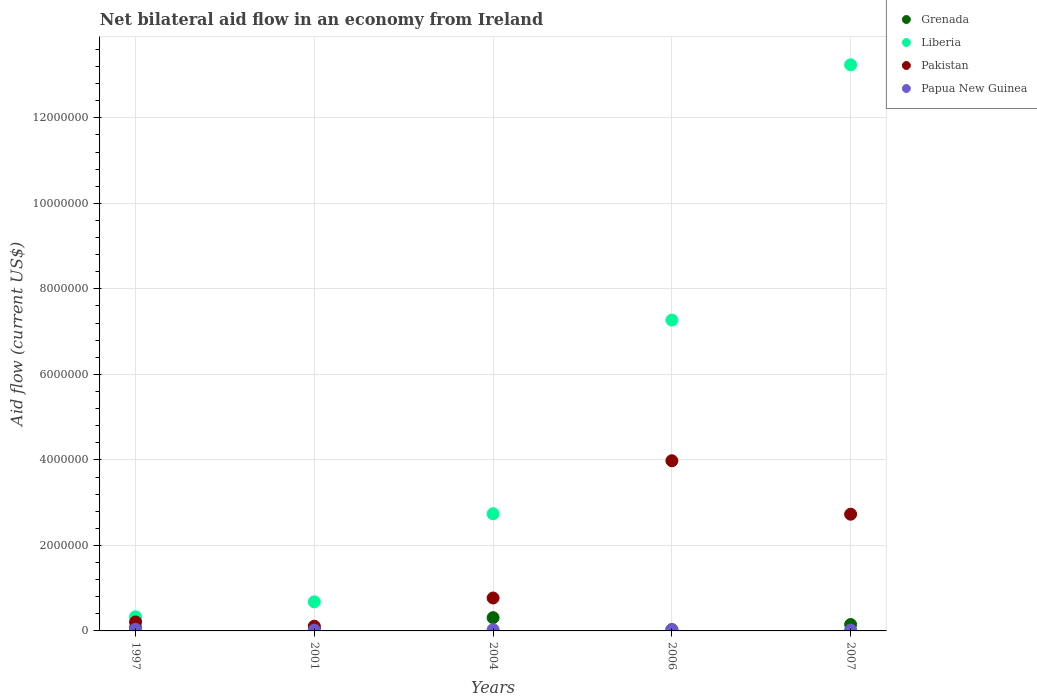How many different coloured dotlines are there?
Your response must be concise. 4. Is the number of dotlines equal to the number of legend labels?
Ensure brevity in your answer.  Yes. What is the net bilateral aid flow in Papua New Guinea in 2001?
Ensure brevity in your answer.  2.00e+04. Across all years, what is the maximum net bilateral aid flow in Pakistan?
Keep it short and to the point. 3.98e+06. Across all years, what is the minimum net bilateral aid flow in Grenada?
Make the answer very short. 3.00e+04. What is the total net bilateral aid flow in Pakistan in the graph?
Your answer should be very brief. 7.80e+06. What is the difference between the net bilateral aid flow in Pakistan in 2004 and that in 2006?
Offer a very short reply. -3.21e+06. What is the difference between the net bilateral aid flow in Liberia in 1997 and the net bilateral aid flow in Papua New Guinea in 2007?
Offer a very short reply. 3.10e+05. What is the average net bilateral aid flow in Liberia per year?
Your response must be concise. 4.85e+06. In the year 2001, what is the difference between the net bilateral aid flow in Pakistan and net bilateral aid flow in Grenada?
Ensure brevity in your answer.  6.00e+04. What is the ratio of the net bilateral aid flow in Pakistan in 2001 to that in 2007?
Offer a terse response. 0.04. Is the net bilateral aid flow in Liberia in 2004 less than that in 2007?
Keep it short and to the point. Yes. Is the difference between the net bilateral aid flow in Pakistan in 2006 and 2007 greater than the difference between the net bilateral aid flow in Grenada in 2006 and 2007?
Offer a very short reply. Yes. Is the sum of the net bilateral aid flow in Pakistan in 2001 and 2006 greater than the maximum net bilateral aid flow in Liberia across all years?
Give a very brief answer. No. Is it the case that in every year, the sum of the net bilateral aid flow in Grenada and net bilateral aid flow in Papua New Guinea  is greater than the sum of net bilateral aid flow in Liberia and net bilateral aid flow in Pakistan?
Give a very brief answer. No. Does the net bilateral aid flow in Grenada monotonically increase over the years?
Your answer should be compact. No. Is the net bilateral aid flow in Grenada strictly less than the net bilateral aid flow in Papua New Guinea over the years?
Offer a very short reply. No. What is the difference between two consecutive major ticks on the Y-axis?
Offer a terse response. 2.00e+06. Are the values on the major ticks of Y-axis written in scientific E-notation?
Provide a short and direct response. No. Does the graph contain any zero values?
Provide a succinct answer. No. Where does the legend appear in the graph?
Give a very brief answer. Top right. What is the title of the graph?
Your response must be concise. Net bilateral aid flow in an economy from Ireland. Does "New Zealand" appear as one of the legend labels in the graph?
Keep it short and to the point. No. What is the label or title of the X-axis?
Ensure brevity in your answer.  Years. What is the label or title of the Y-axis?
Give a very brief answer. Aid flow (current US$). What is the Aid flow (current US$) in Grenada in 1997?
Provide a short and direct response. 8.00e+04. What is the Aid flow (current US$) of Liberia in 1997?
Make the answer very short. 3.30e+05. What is the Aid flow (current US$) of Papua New Guinea in 1997?
Provide a short and direct response. 4.00e+04. What is the Aid flow (current US$) in Grenada in 2001?
Make the answer very short. 5.00e+04. What is the Aid flow (current US$) in Liberia in 2001?
Provide a short and direct response. 6.80e+05. What is the Aid flow (current US$) of Papua New Guinea in 2001?
Keep it short and to the point. 2.00e+04. What is the Aid flow (current US$) of Grenada in 2004?
Keep it short and to the point. 3.10e+05. What is the Aid flow (current US$) of Liberia in 2004?
Keep it short and to the point. 2.74e+06. What is the Aid flow (current US$) of Pakistan in 2004?
Provide a succinct answer. 7.70e+05. What is the Aid flow (current US$) in Grenada in 2006?
Your response must be concise. 3.00e+04. What is the Aid flow (current US$) of Liberia in 2006?
Your answer should be very brief. 7.27e+06. What is the Aid flow (current US$) of Pakistan in 2006?
Provide a succinct answer. 3.98e+06. What is the Aid flow (current US$) in Grenada in 2007?
Provide a succinct answer. 1.50e+05. What is the Aid flow (current US$) in Liberia in 2007?
Your response must be concise. 1.32e+07. What is the Aid flow (current US$) in Pakistan in 2007?
Offer a terse response. 2.73e+06. What is the Aid flow (current US$) of Papua New Guinea in 2007?
Ensure brevity in your answer.  2.00e+04. Across all years, what is the maximum Aid flow (current US$) of Liberia?
Make the answer very short. 1.32e+07. Across all years, what is the maximum Aid flow (current US$) in Pakistan?
Offer a very short reply. 3.98e+06. Across all years, what is the maximum Aid flow (current US$) of Papua New Guinea?
Ensure brevity in your answer.  4.00e+04. Across all years, what is the minimum Aid flow (current US$) of Liberia?
Provide a succinct answer. 3.30e+05. Across all years, what is the minimum Aid flow (current US$) of Pakistan?
Provide a succinct answer. 1.10e+05. Across all years, what is the minimum Aid flow (current US$) in Papua New Guinea?
Keep it short and to the point. 2.00e+04. What is the total Aid flow (current US$) in Grenada in the graph?
Keep it short and to the point. 6.20e+05. What is the total Aid flow (current US$) in Liberia in the graph?
Keep it short and to the point. 2.43e+07. What is the total Aid flow (current US$) of Pakistan in the graph?
Give a very brief answer. 7.80e+06. What is the total Aid flow (current US$) of Papua New Guinea in the graph?
Your answer should be compact. 1.40e+05. What is the difference between the Aid flow (current US$) in Liberia in 1997 and that in 2001?
Ensure brevity in your answer.  -3.50e+05. What is the difference between the Aid flow (current US$) of Pakistan in 1997 and that in 2001?
Keep it short and to the point. 1.00e+05. What is the difference between the Aid flow (current US$) in Papua New Guinea in 1997 and that in 2001?
Keep it short and to the point. 2.00e+04. What is the difference between the Aid flow (current US$) of Liberia in 1997 and that in 2004?
Your answer should be compact. -2.41e+06. What is the difference between the Aid flow (current US$) in Pakistan in 1997 and that in 2004?
Your answer should be compact. -5.60e+05. What is the difference between the Aid flow (current US$) in Papua New Guinea in 1997 and that in 2004?
Provide a succinct answer. 10000. What is the difference between the Aid flow (current US$) in Grenada in 1997 and that in 2006?
Provide a succinct answer. 5.00e+04. What is the difference between the Aid flow (current US$) of Liberia in 1997 and that in 2006?
Your answer should be compact. -6.94e+06. What is the difference between the Aid flow (current US$) in Pakistan in 1997 and that in 2006?
Ensure brevity in your answer.  -3.77e+06. What is the difference between the Aid flow (current US$) in Papua New Guinea in 1997 and that in 2006?
Make the answer very short. 10000. What is the difference between the Aid flow (current US$) of Grenada in 1997 and that in 2007?
Provide a succinct answer. -7.00e+04. What is the difference between the Aid flow (current US$) in Liberia in 1997 and that in 2007?
Make the answer very short. -1.29e+07. What is the difference between the Aid flow (current US$) of Pakistan in 1997 and that in 2007?
Your answer should be compact. -2.52e+06. What is the difference between the Aid flow (current US$) of Papua New Guinea in 1997 and that in 2007?
Your answer should be very brief. 2.00e+04. What is the difference between the Aid flow (current US$) of Liberia in 2001 and that in 2004?
Provide a short and direct response. -2.06e+06. What is the difference between the Aid flow (current US$) of Pakistan in 2001 and that in 2004?
Make the answer very short. -6.60e+05. What is the difference between the Aid flow (current US$) of Grenada in 2001 and that in 2006?
Your answer should be compact. 2.00e+04. What is the difference between the Aid flow (current US$) of Liberia in 2001 and that in 2006?
Offer a very short reply. -6.59e+06. What is the difference between the Aid flow (current US$) in Pakistan in 2001 and that in 2006?
Your answer should be very brief. -3.87e+06. What is the difference between the Aid flow (current US$) of Papua New Guinea in 2001 and that in 2006?
Your answer should be very brief. -10000. What is the difference between the Aid flow (current US$) of Liberia in 2001 and that in 2007?
Provide a succinct answer. -1.26e+07. What is the difference between the Aid flow (current US$) in Pakistan in 2001 and that in 2007?
Your response must be concise. -2.62e+06. What is the difference between the Aid flow (current US$) of Papua New Guinea in 2001 and that in 2007?
Provide a short and direct response. 0. What is the difference between the Aid flow (current US$) of Liberia in 2004 and that in 2006?
Offer a very short reply. -4.53e+06. What is the difference between the Aid flow (current US$) in Pakistan in 2004 and that in 2006?
Provide a short and direct response. -3.21e+06. What is the difference between the Aid flow (current US$) in Papua New Guinea in 2004 and that in 2006?
Give a very brief answer. 0. What is the difference between the Aid flow (current US$) of Grenada in 2004 and that in 2007?
Keep it short and to the point. 1.60e+05. What is the difference between the Aid flow (current US$) of Liberia in 2004 and that in 2007?
Your answer should be compact. -1.05e+07. What is the difference between the Aid flow (current US$) in Pakistan in 2004 and that in 2007?
Give a very brief answer. -1.96e+06. What is the difference between the Aid flow (current US$) in Liberia in 2006 and that in 2007?
Ensure brevity in your answer.  -5.97e+06. What is the difference between the Aid flow (current US$) of Pakistan in 2006 and that in 2007?
Make the answer very short. 1.25e+06. What is the difference between the Aid flow (current US$) in Papua New Guinea in 2006 and that in 2007?
Your answer should be very brief. 10000. What is the difference between the Aid flow (current US$) in Grenada in 1997 and the Aid flow (current US$) in Liberia in 2001?
Your response must be concise. -6.00e+05. What is the difference between the Aid flow (current US$) of Grenada in 1997 and the Aid flow (current US$) of Pakistan in 2001?
Make the answer very short. -3.00e+04. What is the difference between the Aid flow (current US$) in Grenada in 1997 and the Aid flow (current US$) in Papua New Guinea in 2001?
Your response must be concise. 6.00e+04. What is the difference between the Aid flow (current US$) in Liberia in 1997 and the Aid flow (current US$) in Pakistan in 2001?
Make the answer very short. 2.20e+05. What is the difference between the Aid flow (current US$) in Grenada in 1997 and the Aid flow (current US$) in Liberia in 2004?
Your response must be concise. -2.66e+06. What is the difference between the Aid flow (current US$) in Grenada in 1997 and the Aid flow (current US$) in Pakistan in 2004?
Keep it short and to the point. -6.90e+05. What is the difference between the Aid flow (current US$) in Liberia in 1997 and the Aid flow (current US$) in Pakistan in 2004?
Ensure brevity in your answer.  -4.40e+05. What is the difference between the Aid flow (current US$) in Grenada in 1997 and the Aid flow (current US$) in Liberia in 2006?
Your response must be concise. -7.19e+06. What is the difference between the Aid flow (current US$) in Grenada in 1997 and the Aid flow (current US$) in Pakistan in 2006?
Your answer should be very brief. -3.90e+06. What is the difference between the Aid flow (current US$) in Liberia in 1997 and the Aid flow (current US$) in Pakistan in 2006?
Offer a terse response. -3.65e+06. What is the difference between the Aid flow (current US$) of Grenada in 1997 and the Aid flow (current US$) of Liberia in 2007?
Give a very brief answer. -1.32e+07. What is the difference between the Aid flow (current US$) in Grenada in 1997 and the Aid flow (current US$) in Pakistan in 2007?
Offer a very short reply. -2.65e+06. What is the difference between the Aid flow (current US$) of Liberia in 1997 and the Aid flow (current US$) of Pakistan in 2007?
Make the answer very short. -2.40e+06. What is the difference between the Aid flow (current US$) of Pakistan in 1997 and the Aid flow (current US$) of Papua New Guinea in 2007?
Provide a succinct answer. 1.90e+05. What is the difference between the Aid flow (current US$) in Grenada in 2001 and the Aid flow (current US$) in Liberia in 2004?
Give a very brief answer. -2.69e+06. What is the difference between the Aid flow (current US$) of Grenada in 2001 and the Aid flow (current US$) of Pakistan in 2004?
Your answer should be very brief. -7.20e+05. What is the difference between the Aid flow (current US$) of Grenada in 2001 and the Aid flow (current US$) of Papua New Guinea in 2004?
Your answer should be compact. 2.00e+04. What is the difference between the Aid flow (current US$) of Liberia in 2001 and the Aid flow (current US$) of Pakistan in 2004?
Your response must be concise. -9.00e+04. What is the difference between the Aid flow (current US$) of Liberia in 2001 and the Aid flow (current US$) of Papua New Guinea in 2004?
Offer a very short reply. 6.50e+05. What is the difference between the Aid flow (current US$) of Pakistan in 2001 and the Aid flow (current US$) of Papua New Guinea in 2004?
Offer a very short reply. 8.00e+04. What is the difference between the Aid flow (current US$) in Grenada in 2001 and the Aid flow (current US$) in Liberia in 2006?
Provide a short and direct response. -7.22e+06. What is the difference between the Aid flow (current US$) in Grenada in 2001 and the Aid flow (current US$) in Pakistan in 2006?
Provide a short and direct response. -3.93e+06. What is the difference between the Aid flow (current US$) of Liberia in 2001 and the Aid flow (current US$) of Pakistan in 2006?
Keep it short and to the point. -3.30e+06. What is the difference between the Aid flow (current US$) of Liberia in 2001 and the Aid flow (current US$) of Papua New Guinea in 2006?
Your response must be concise. 6.50e+05. What is the difference between the Aid flow (current US$) in Grenada in 2001 and the Aid flow (current US$) in Liberia in 2007?
Make the answer very short. -1.32e+07. What is the difference between the Aid flow (current US$) of Grenada in 2001 and the Aid flow (current US$) of Pakistan in 2007?
Your response must be concise. -2.68e+06. What is the difference between the Aid flow (current US$) in Liberia in 2001 and the Aid flow (current US$) in Pakistan in 2007?
Your answer should be compact. -2.05e+06. What is the difference between the Aid flow (current US$) of Grenada in 2004 and the Aid flow (current US$) of Liberia in 2006?
Your answer should be very brief. -6.96e+06. What is the difference between the Aid flow (current US$) of Grenada in 2004 and the Aid flow (current US$) of Pakistan in 2006?
Ensure brevity in your answer.  -3.67e+06. What is the difference between the Aid flow (current US$) of Liberia in 2004 and the Aid flow (current US$) of Pakistan in 2006?
Provide a short and direct response. -1.24e+06. What is the difference between the Aid flow (current US$) in Liberia in 2004 and the Aid flow (current US$) in Papua New Guinea in 2006?
Your response must be concise. 2.71e+06. What is the difference between the Aid flow (current US$) in Pakistan in 2004 and the Aid flow (current US$) in Papua New Guinea in 2006?
Ensure brevity in your answer.  7.40e+05. What is the difference between the Aid flow (current US$) of Grenada in 2004 and the Aid flow (current US$) of Liberia in 2007?
Provide a short and direct response. -1.29e+07. What is the difference between the Aid flow (current US$) of Grenada in 2004 and the Aid flow (current US$) of Pakistan in 2007?
Provide a short and direct response. -2.42e+06. What is the difference between the Aid flow (current US$) in Liberia in 2004 and the Aid flow (current US$) in Pakistan in 2007?
Make the answer very short. 10000. What is the difference between the Aid flow (current US$) in Liberia in 2004 and the Aid flow (current US$) in Papua New Guinea in 2007?
Your response must be concise. 2.72e+06. What is the difference between the Aid flow (current US$) in Pakistan in 2004 and the Aid flow (current US$) in Papua New Guinea in 2007?
Offer a very short reply. 7.50e+05. What is the difference between the Aid flow (current US$) of Grenada in 2006 and the Aid flow (current US$) of Liberia in 2007?
Give a very brief answer. -1.32e+07. What is the difference between the Aid flow (current US$) in Grenada in 2006 and the Aid flow (current US$) in Pakistan in 2007?
Give a very brief answer. -2.70e+06. What is the difference between the Aid flow (current US$) of Liberia in 2006 and the Aid flow (current US$) of Pakistan in 2007?
Make the answer very short. 4.54e+06. What is the difference between the Aid flow (current US$) in Liberia in 2006 and the Aid flow (current US$) in Papua New Guinea in 2007?
Provide a succinct answer. 7.25e+06. What is the difference between the Aid flow (current US$) in Pakistan in 2006 and the Aid flow (current US$) in Papua New Guinea in 2007?
Your answer should be very brief. 3.96e+06. What is the average Aid flow (current US$) in Grenada per year?
Give a very brief answer. 1.24e+05. What is the average Aid flow (current US$) of Liberia per year?
Offer a very short reply. 4.85e+06. What is the average Aid flow (current US$) of Pakistan per year?
Your answer should be very brief. 1.56e+06. What is the average Aid flow (current US$) of Papua New Guinea per year?
Provide a short and direct response. 2.80e+04. In the year 1997, what is the difference between the Aid flow (current US$) of Grenada and Aid flow (current US$) of Liberia?
Your response must be concise. -2.50e+05. In the year 1997, what is the difference between the Aid flow (current US$) in Grenada and Aid flow (current US$) in Pakistan?
Give a very brief answer. -1.30e+05. In the year 1997, what is the difference between the Aid flow (current US$) in Grenada and Aid flow (current US$) in Papua New Guinea?
Your answer should be compact. 4.00e+04. In the year 2001, what is the difference between the Aid flow (current US$) of Grenada and Aid flow (current US$) of Liberia?
Provide a succinct answer. -6.30e+05. In the year 2001, what is the difference between the Aid flow (current US$) in Grenada and Aid flow (current US$) in Papua New Guinea?
Keep it short and to the point. 3.00e+04. In the year 2001, what is the difference between the Aid flow (current US$) in Liberia and Aid flow (current US$) in Pakistan?
Keep it short and to the point. 5.70e+05. In the year 2001, what is the difference between the Aid flow (current US$) in Liberia and Aid flow (current US$) in Papua New Guinea?
Your answer should be very brief. 6.60e+05. In the year 2001, what is the difference between the Aid flow (current US$) in Pakistan and Aid flow (current US$) in Papua New Guinea?
Ensure brevity in your answer.  9.00e+04. In the year 2004, what is the difference between the Aid flow (current US$) in Grenada and Aid flow (current US$) in Liberia?
Your answer should be compact. -2.43e+06. In the year 2004, what is the difference between the Aid flow (current US$) of Grenada and Aid flow (current US$) of Pakistan?
Provide a succinct answer. -4.60e+05. In the year 2004, what is the difference between the Aid flow (current US$) in Grenada and Aid flow (current US$) in Papua New Guinea?
Keep it short and to the point. 2.80e+05. In the year 2004, what is the difference between the Aid flow (current US$) of Liberia and Aid flow (current US$) of Pakistan?
Keep it short and to the point. 1.97e+06. In the year 2004, what is the difference between the Aid flow (current US$) of Liberia and Aid flow (current US$) of Papua New Guinea?
Your answer should be very brief. 2.71e+06. In the year 2004, what is the difference between the Aid flow (current US$) of Pakistan and Aid flow (current US$) of Papua New Guinea?
Your answer should be very brief. 7.40e+05. In the year 2006, what is the difference between the Aid flow (current US$) in Grenada and Aid flow (current US$) in Liberia?
Your answer should be compact. -7.24e+06. In the year 2006, what is the difference between the Aid flow (current US$) of Grenada and Aid flow (current US$) of Pakistan?
Offer a terse response. -3.95e+06. In the year 2006, what is the difference between the Aid flow (current US$) of Grenada and Aid flow (current US$) of Papua New Guinea?
Make the answer very short. 0. In the year 2006, what is the difference between the Aid flow (current US$) of Liberia and Aid flow (current US$) of Pakistan?
Your answer should be very brief. 3.29e+06. In the year 2006, what is the difference between the Aid flow (current US$) in Liberia and Aid flow (current US$) in Papua New Guinea?
Offer a very short reply. 7.24e+06. In the year 2006, what is the difference between the Aid flow (current US$) of Pakistan and Aid flow (current US$) of Papua New Guinea?
Provide a short and direct response. 3.95e+06. In the year 2007, what is the difference between the Aid flow (current US$) in Grenada and Aid flow (current US$) in Liberia?
Keep it short and to the point. -1.31e+07. In the year 2007, what is the difference between the Aid flow (current US$) in Grenada and Aid flow (current US$) in Pakistan?
Your response must be concise. -2.58e+06. In the year 2007, what is the difference between the Aid flow (current US$) in Grenada and Aid flow (current US$) in Papua New Guinea?
Make the answer very short. 1.30e+05. In the year 2007, what is the difference between the Aid flow (current US$) in Liberia and Aid flow (current US$) in Pakistan?
Give a very brief answer. 1.05e+07. In the year 2007, what is the difference between the Aid flow (current US$) in Liberia and Aid flow (current US$) in Papua New Guinea?
Provide a short and direct response. 1.32e+07. In the year 2007, what is the difference between the Aid flow (current US$) of Pakistan and Aid flow (current US$) of Papua New Guinea?
Your answer should be compact. 2.71e+06. What is the ratio of the Aid flow (current US$) in Grenada in 1997 to that in 2001?
Give a very brief answer. 1.6. What is the ratio of the Aid flow (current US$) in Liberia in 1997 to that in 2001?
Your answer should be compact. 0.49. What is the ratio of the Aid flow (current US$) of Pakistan in 1997 to that in 2001?
Offer a very short reply. 1.91. What is the ratio of the Aid flow (current US$) in Papua New Guinea in 1997 to that in 2001?
Ensure brevity in your answer.  2. What is the ratio of the Aid flow (current US$) in Grenada in 1997 to that in 2004?
Keep it short and to the point. 0.26. What is the ratio of the Aid flow (current US$) of Liberia in 1997 to that in 2004?
Offer a very short reply. 0.12. What is the ratio of the Aid flow (current US$) in Pakistan in 1997 to that in 2004?
Provide a succinct answer. 0.27. What is the ratio of the Aid flow (current US$) of Grenada in 1997 to that in 2006?
Provide a succinct answer. 2.67. What is the ratio of the Aid flow (current US$) in Liberia in 1997 to that in 2006?
Make the answer very short. 0.05. What is the ratio of the Aid flow (current US$) of Pakistan in 1997 to that in 2006?
Offer a terse response. 0.05. What is the ratio of the Aid flow (current US$) in Grenada in 1997 to that in 2007?
Provide a short and direct response. 0.53. What is the ratio of the Aid flow (current US$) in Liberia in 1997 to that in 2007?
Provide a succinct answer. 0.02. What is the ratio of the Aid flow (current US$) of Pakistan in 1997 to that in 2007?
Offer a terse response. 0.08. What is the ratio of the Aid flow (current US$) in Grenada in 2001 to that in 2004?
Make the answer very short. 0.16. What is the ratio of the Aid flow (current US$) in Liberia in 2001 to that in 2004?
Your answer should be very brief. 0.25. What is the ratio of the Aid flow (current US$) in Pakistan in 2001 to that in 2004?
Offer a terse response. 0.14. What is the ratio of the Aid flow (current US$) in Papua New Guinea in 2001 to that in 2004?
Provide a short and direct response. 0.67. What is the ratio of the Aid flow (current US$) in Liberia in 2001 to that in 2006?
Make the answer very short. 0.09. What is the ratio of the Aid flow (current US$) in Pakistan in 2001 to that in 2006?
Provide a succinct answer. 0.03. What is the ratio of the Aid flow (current US$) of Liberia in 2001 to that in 2007?
Your answer should be compact. 0.05. What is the ratio of the Aid flow (current US$) of Pakistan in 2001 to that in 2007?
Offer a terse response. 0.04. What is the ratio of the Aid flow (current US$) in Papua New Guinea in 2001 to that in 2007?
Offer a very short reply. 1. What is the ratio of the Aid flow (current US$) of Grenada in 2004 to that in 2006?
Ensure brevity in your answer.  10.33. What is the ratio of the Aid flow (current US$) of Liberia in 2004 to that in 2006?
Provide a short and direct response. 0.38. What is the ratio of the Aid flow (current US$) of Pakistan in 2004 to that in 2006?
Give a very brief answer. 0.19. What is the ratio of the Aid flow (current US$) of Grenada in 2004 to that in 2007?
Ensure brevity in your answer.  2.07. What is the ratio of the Aid flow (current US$) of Liberia in 2004 to that in 2007?
Your answer should be compact. 0.21. What is the ratio of the Aid flow (current US$) of Pakistan in 2004 to that in 2007?
Ensure brevity in your answer.  0.28. What is the ratio of the Aid flow (current US$) in Grenada in 2006 to that in 2007?
Ensure brevity in your answer.  0.2. What is the ratio of the Aid flow (current US$) in Liberia in 2006 to that in 2007?
Make the answer very short. 0.55. What is the ratio of the Aid flow (current US$) in Pakistan in 2006 to that in 2007?
Ensure brevity in your answer.  1.46. What is the ratio of the Aid flow (current US$) in Papua New Guinea in 2006 to that in 2007?
Make the answer very short. 1.5. What is the difference between the highest and the second highest Aid flow (current US$) in Liberia?
Make the answer very short. 5.97e+06. What is the difference between the highest and the second highest Aid flow (current US$) of Pakistan?
Ensure brevity in your answer.  1.25e+06. What is the difference between the highest and the lowest Aid flow (current US$) in Grenada?
Your answer should be compact. 2.80e+05. What is the difference between the highest and the lowest Aid flow (current US$) of Liberia?
Your answer should be very brief. 1.29e+07. What is the difference between the highest and the lowest Aid flow (current US$) of Pakistan?
Give a very brief answer. 3.87e+06. 